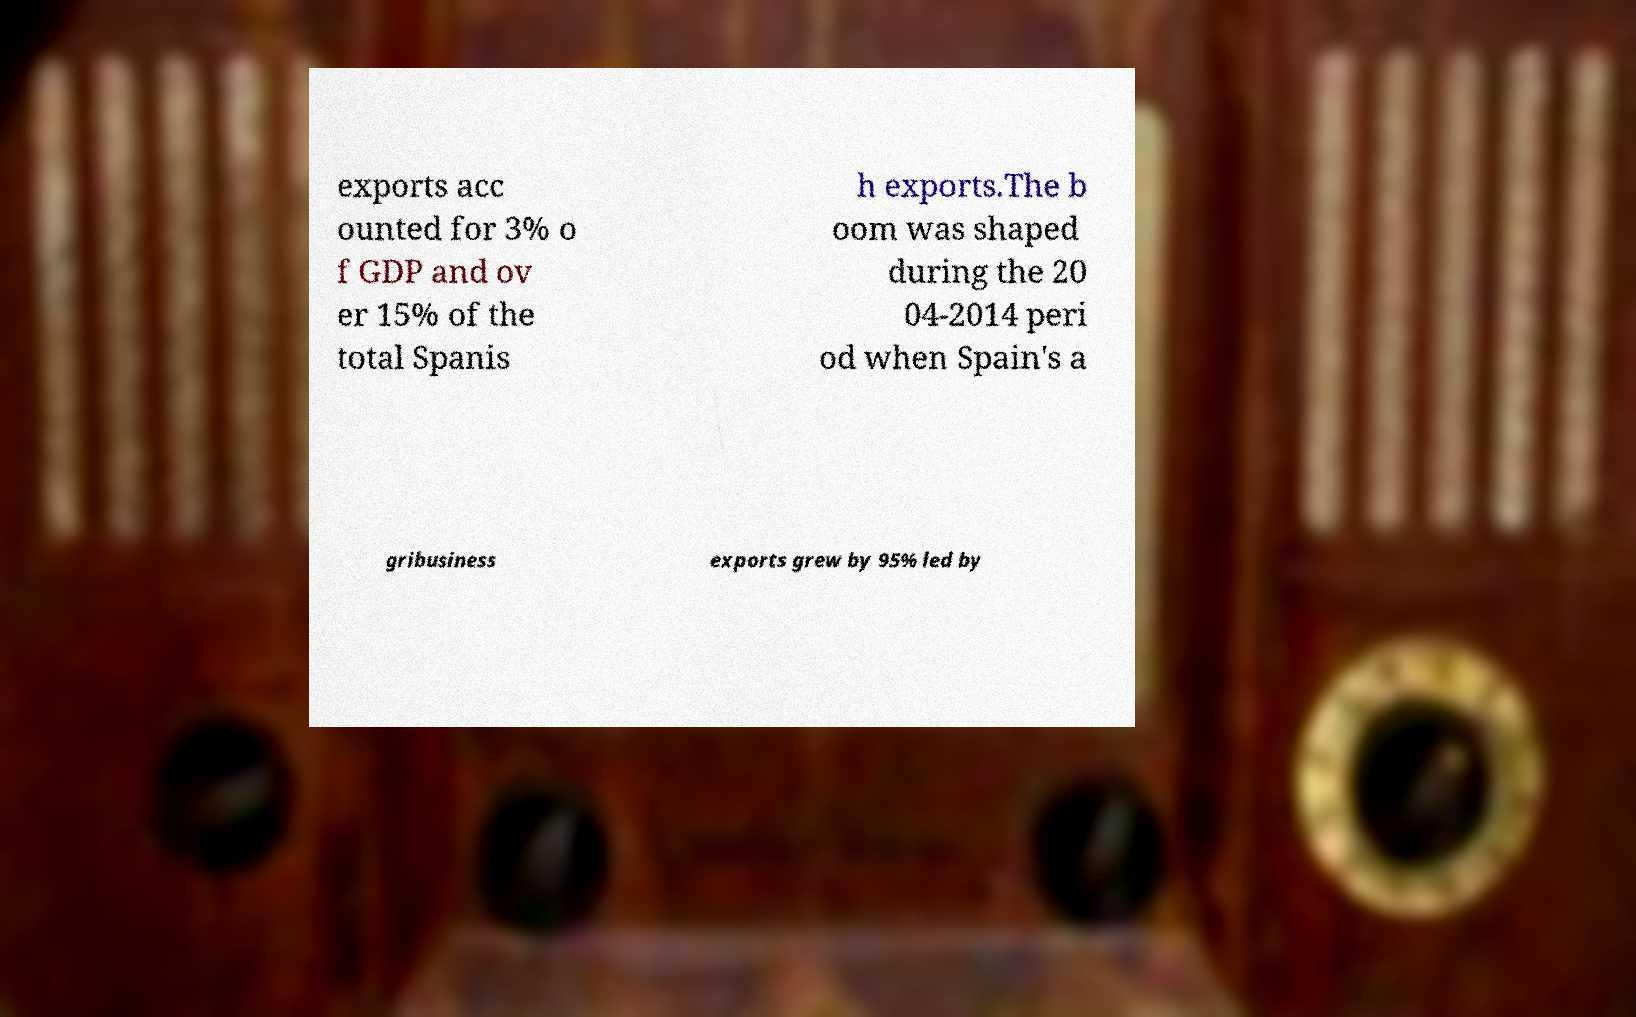Please read and relay the text visible in this image. What does it say? exports acc ounted for 3% o f GDP and ov er 15% of the total Spanis h exports.The b oom was shaped during the 20 04-2014 peri od when Spain's a gribusiness exports grew by 95% led by 